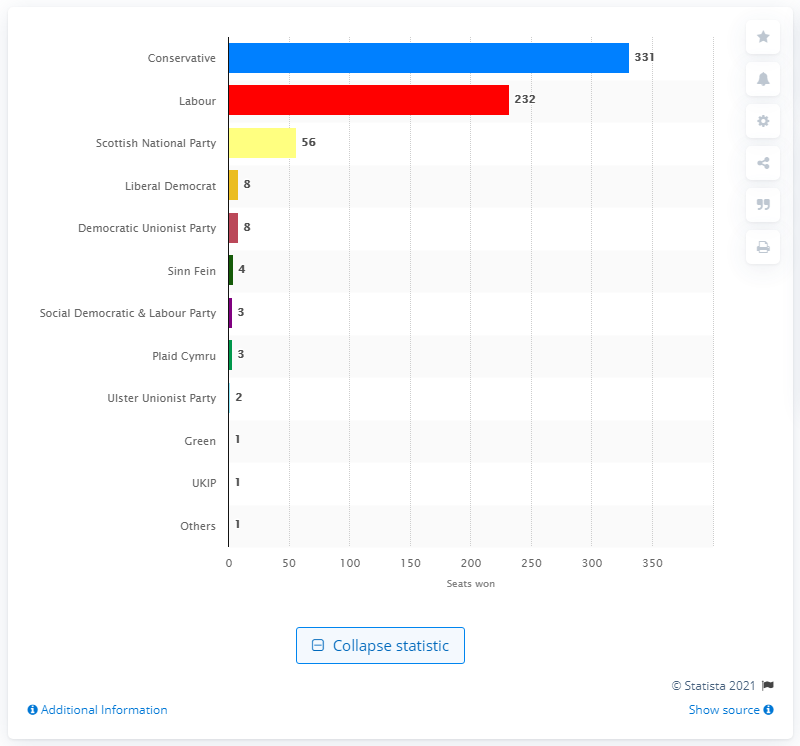Draw attention to some important aspects in this diagram. The Scottish National Party (SNP) won 56 seats in Scotland in the most recent election. 